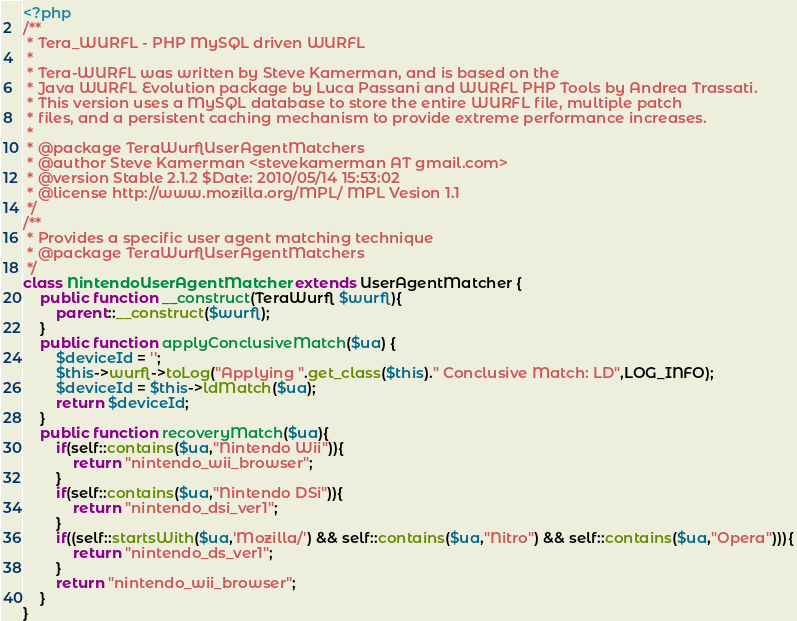Convert code to text. <code><loc_0><loc_0><loc_500><loc_500><_PHP_><?php
/**
 * Tera_WURFL - PHP MySQL driven WURFL
 * 
 * Tera-WURFL was written by Steve Kamerman, and is based on the
 * Java WURFL Evolution package by Luca Passani and WURFL PHP Tools by Andrea Trassati.
 * This version uses a MySQL database to store the entire WURFL file, multiple patch
 * files, and a persistent caching mechanism to provide extreme performance increases.
 * 
 * @package TeraWurflUserAgentMatchers
 * @author Steve Kamerman <stevekamerman AT gmail.com>
 * @version Stable 2.1.2 $Date: 2010/05/14 15:53:02
 * @license http://www.mozilla.org/MPL/ MPL Vesion 1.1
 */
/**
 * Provides a specific user agent matching technique
 * @package TeraWurflUserAgentMatchers
 */
class NintendoUserAgentMatcher extends UserAgentMatcher {
	public function __construct(TeraWurfl $wurfl){
		parent::__construct($wurfl);
	}
	public function applyConclusiveMatch($ua) {
		$deviceId = '';
		$this->wurfl->toLog("Applying ".get_class($this)." Conclusive Match: LD",LOG_INFO);
		$deviceId = $this->ldMatch($ua);
		return $deviceId;
	}
	public function recoveryMatch($ua){
		if(self::contains($ua,"Nintendo Wii")){
			return "nintendo_wii_browser";
		}
		if(self::contains($ua,"Nintendo DSi")){
			return "nintendo_dsi_ver1";
		}
		if((self::startsWith($ua,'Mozilla/') && self::contains($ua,"Nitro") && self::contains($ua,"Opera"))){
			return "nintendo_ds_ver1";
		}
		return "nintendo_wii_browser";
	}
}
</code> 